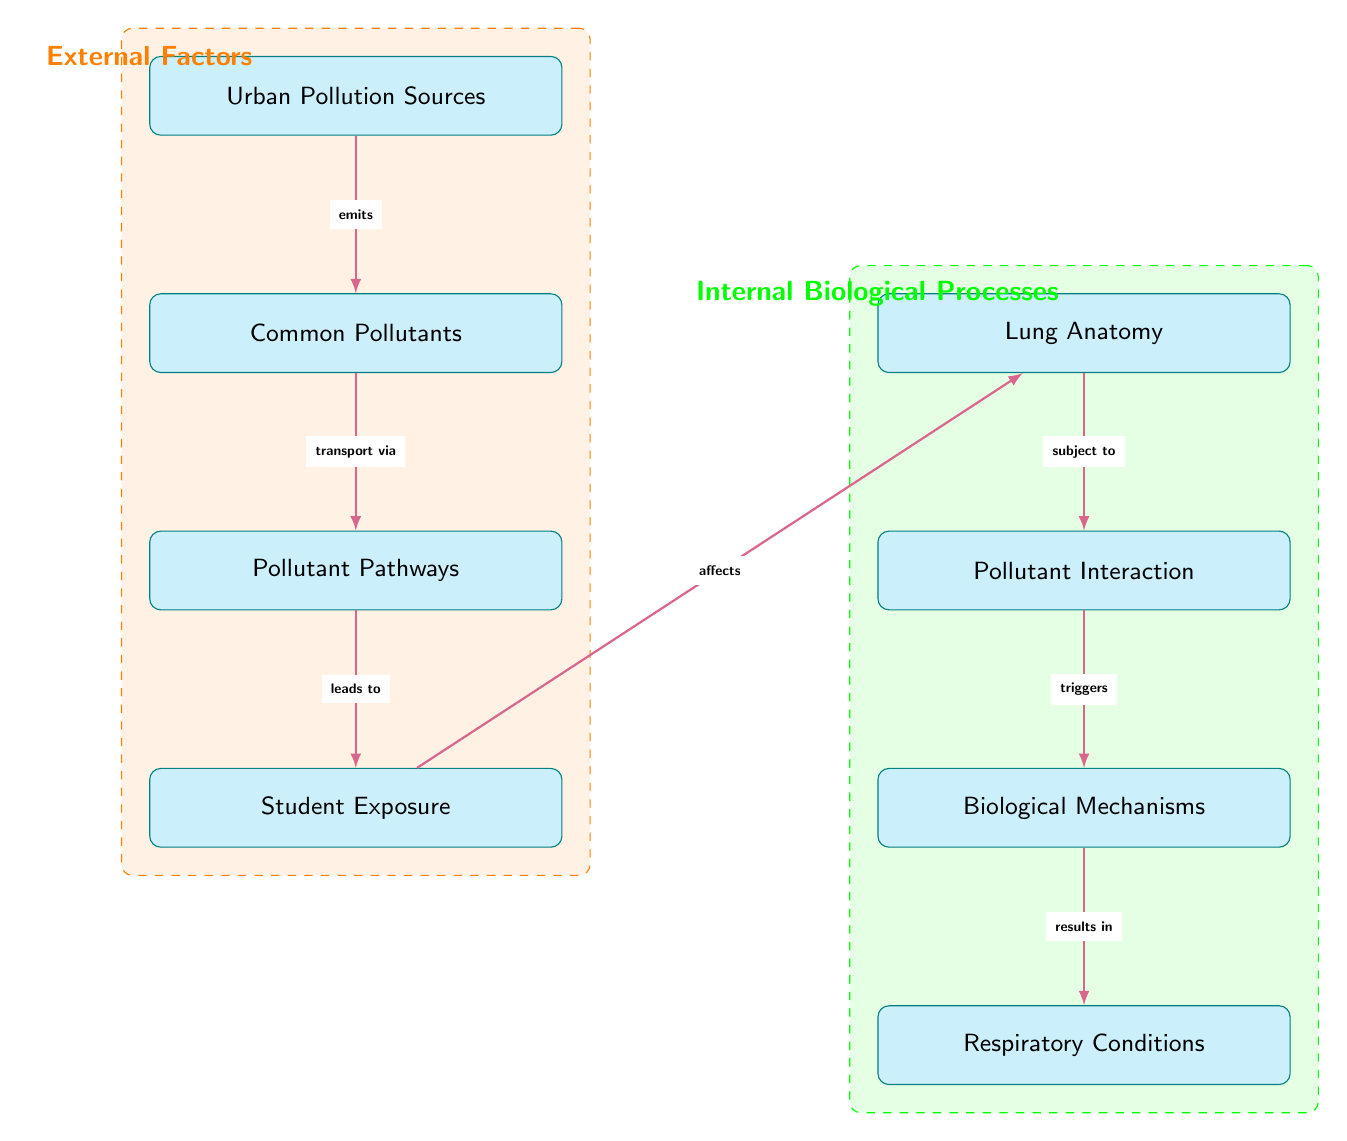What are the Urban Pollution Sources? The diagram mentions "Urban Pollution Sources" as the starting point, indicating it includes various sources that contribute to pollution in urban areas.
Answer: Urban Pollution Sources What follows after Common Pollutants in the diagram? The direct connection from "Common Pollutants" leads to "Pollutant Pathways," signifying the progression from pollutants to their movement in the environment.
Answer: Pollutant Pathways How many nodes are present in the Biological Mechanisms section? There are three nodes in the Biological Mechanisms section: "Pollutant Interaction," "Biological Mechanisms," and "Respiratory Conditions."
Answer: 3 What leads to Student Exposure according to the diagram? "Pollutant Pathways" are defined as leading to "Student Exposure," indicating how pollutants travel and ultimately affect students.
Answer: Pollutant Pathways What triggers Biological Mechanisms in the diagram? The arrow shows that "Pollutant Interaction" is what triggers "Biological Mechanisms," demonstrating that pollutants interact with the lungs to initiate biological responses.
Answer: Pollutant Interaction How do students get affected according to the diagram? The flow from "Student Exposure" indicates that the exposure leads to effects on the "Lung Anatomy," highlighting the impact of environmental factors on student health.
Answer: Lung Anatomy What do Respiratory Conditions result from? The diagram states that "Respiratory Conditions" result from "Biological Mechanisms," implying that the underlying biological responses lead to specific health outcomes like asthma.
Answer: Biological Mechanisms What is the category for the left side of the diagram? The left side of the diagram is labeled as "External Factors," which encompasses all the environmental pollutants and sources affecting student health.
Answer: External Factors What does the green section of the diagram represent? The green section of the diagram represents "Internal Biological Processes," indicating the internal reactions and mechanisms occurring in the body due to external exposure.
Answer: Internal Biological Processes 